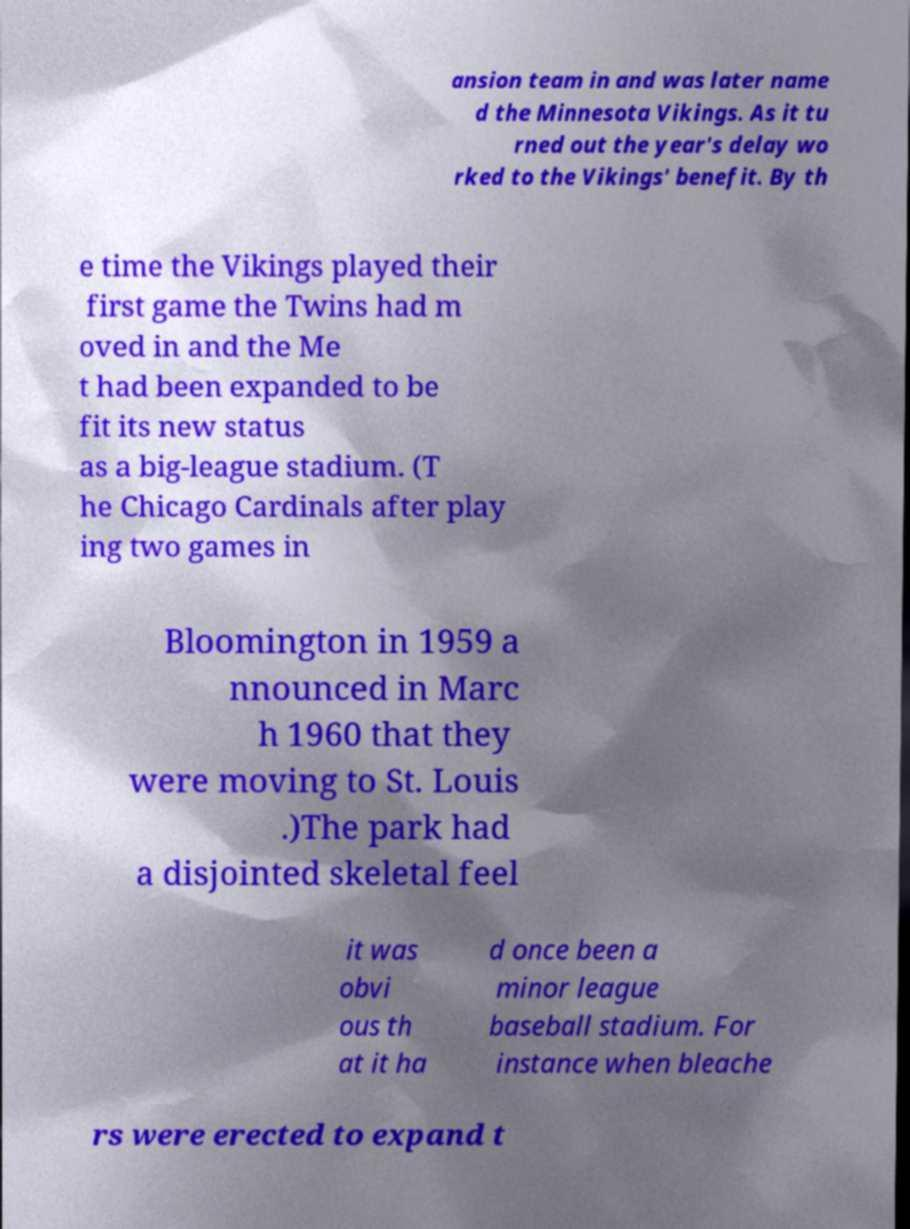What messages or text are displayed in this image? I need them in a readable, typed format. ansion team in and was later name d the Minnesota Vikings. As it tu rned out the year's delay wo rked to the Vikings' benefit. By th e time the Vikings played their first game the Twins had m oved in and the Me t had been expanded to be fit its new status as a big-league stadium. (T he Chicago Cardinals after play ing two games in Bloomington in 1959 a nnounced in Marc h 1960 that they were moving to St. Louis .)The park had a disjointed skeletal feel it was obvi ous th at it ha d once been a minor league baseball stadium. For instance when bleache rs were erected to expand t 